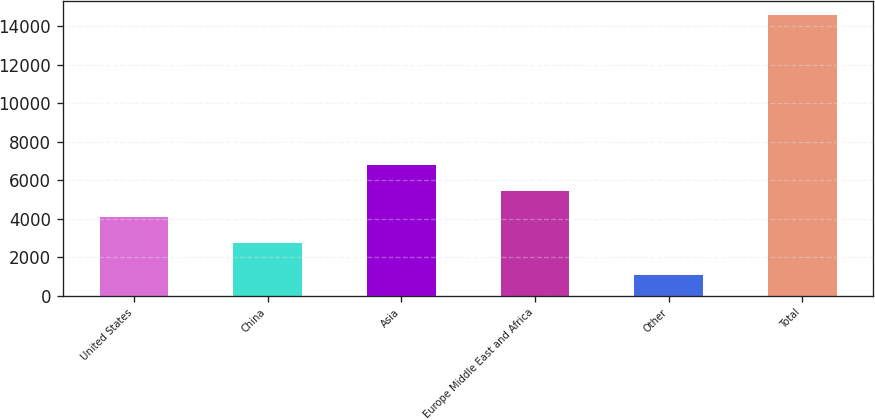Convert chart to OTSL. <chart><loc_0><loc_0><loc_500><loc_500><bar_chart><fcel>United States<fcel>China<fcel>Asia<fcel>Europe Middle East and Africa<fcel>Other<fcel>Total<nl><fcel>4076.1<fcel>2726<fcel>6776.3<fcel>5426.2<fcel>1071<fcel>14572<nl></chart> 